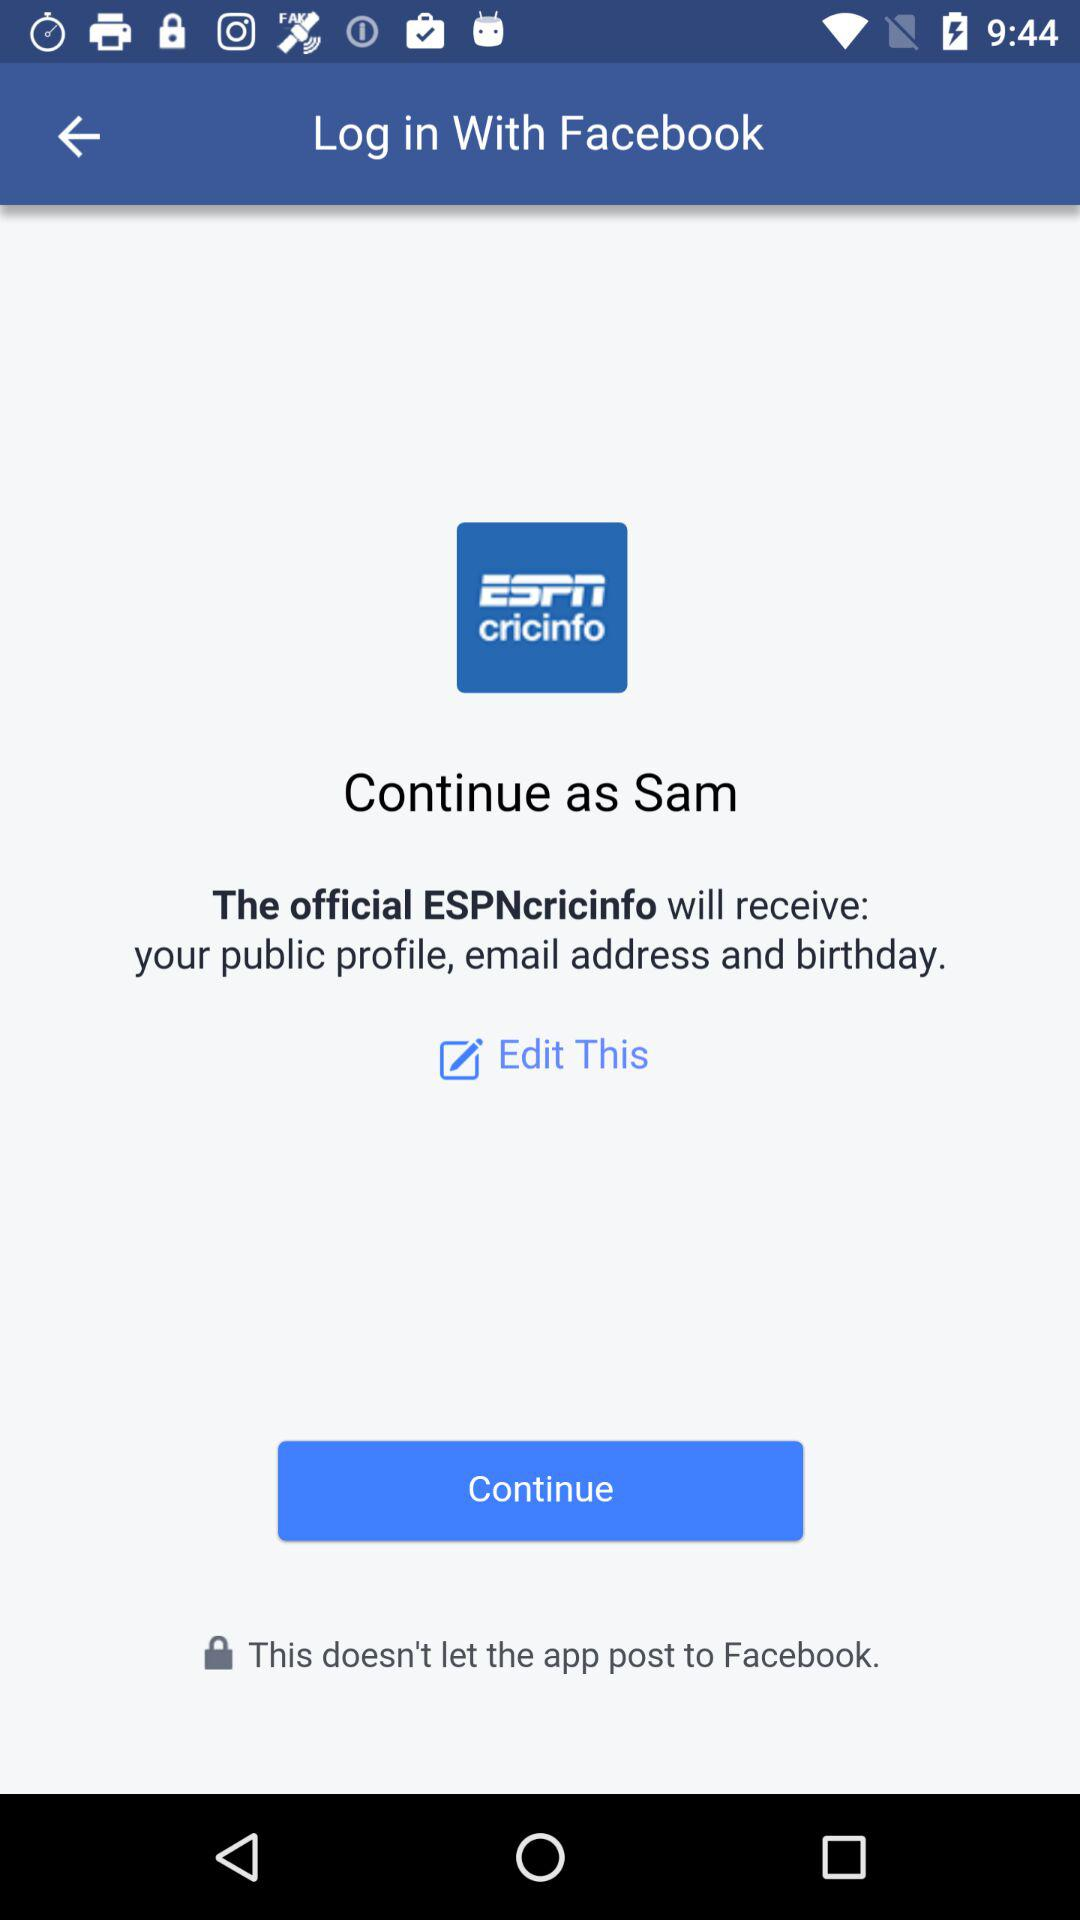Which application is asking for permission? The application asking for permission is "The official ESPNcricinfo". 